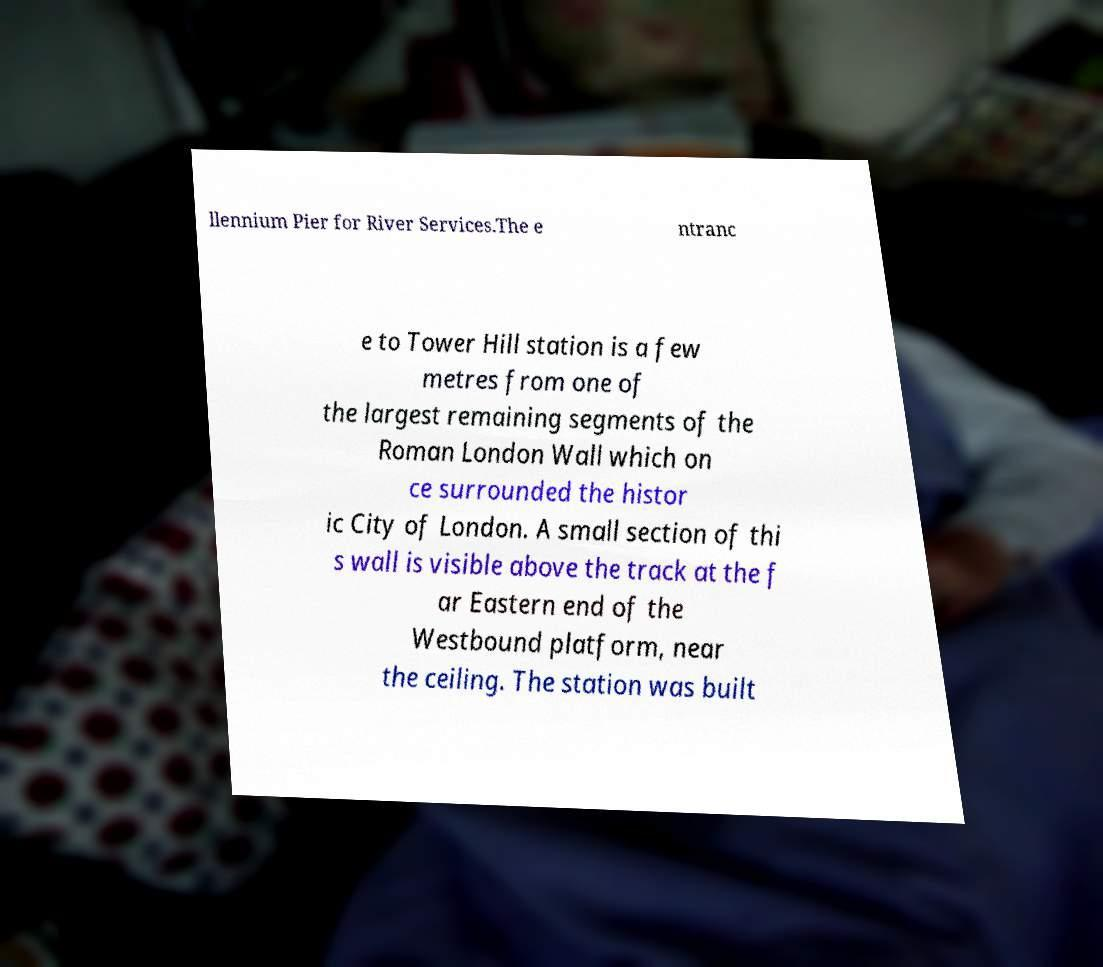Please read and relay the text visible in this image. What does it say? llennium Pier for River Services.The e ntranc e to Tower Hill station is a few metres from one of the largest remaining segments of the Roman London Wall which on ce surrounded the histor ic City of London. A small section of thi s wall is visible above the track at the f ar Eastern end of the Westbound platform, near the ceiling. The station was built 